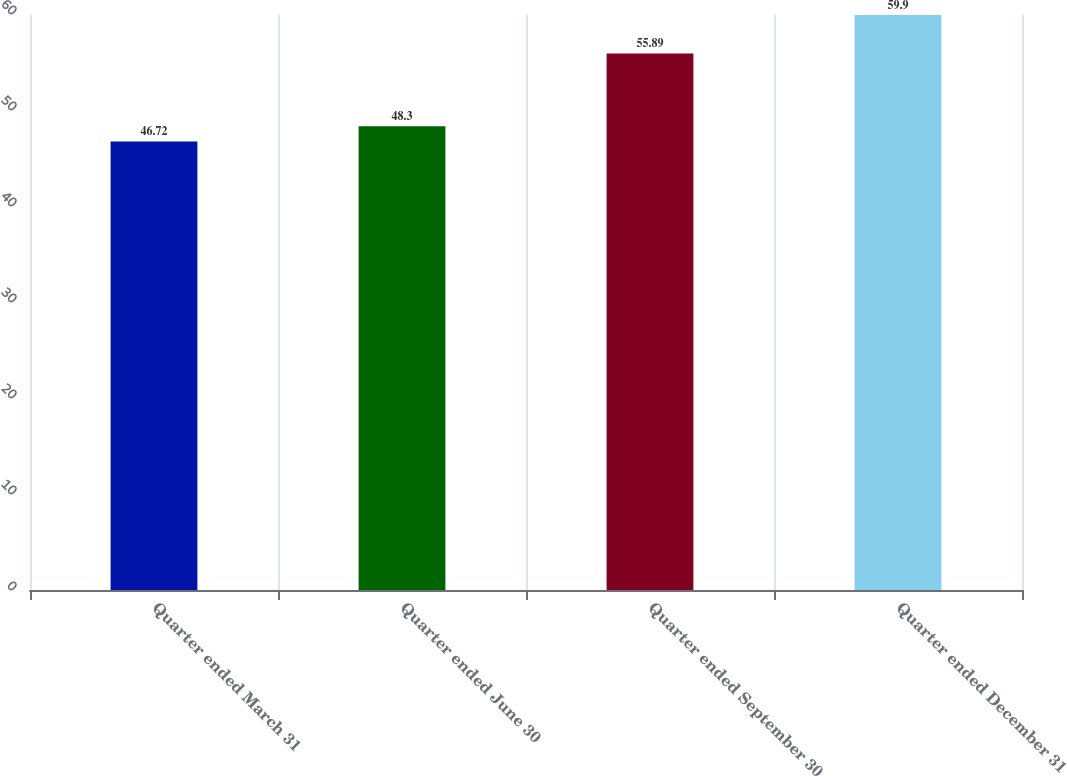Convert chart to OTSL. <chart><loc_0><loc_0><loc_500><loc_500><bar_chart><fcel>Quarter ended March 31<fcel>Quarter ended June 30<fcel>Quarter ended September 30<fcel>Quarter ended December 31<nl><fcel>46.72<fcel>48.3<fcel>55.89<fcel>59.9<nl></chart> 